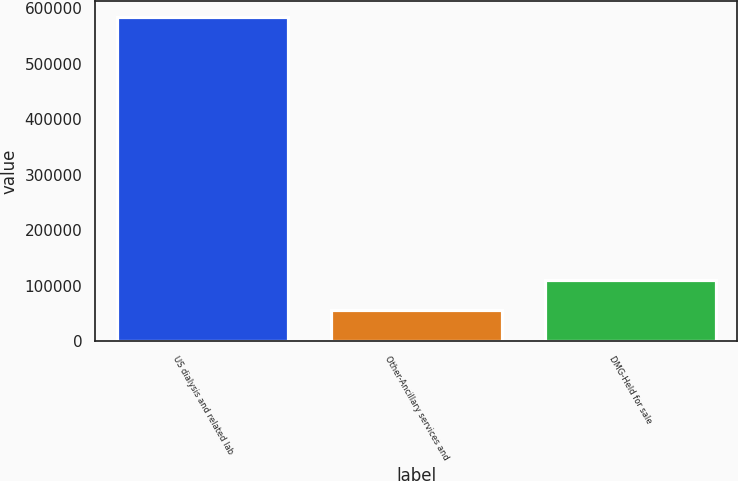Convert chart. <chart><loc_0><loc_0><loc_500><loc_500><bar_chart><fcel>US dialysis and related lab<fcel>Other-Ancillary services and<fcel>DMG-Held for sale<nl><fcel>584513<fcel>56685<fcel>109468<nl></chart> 